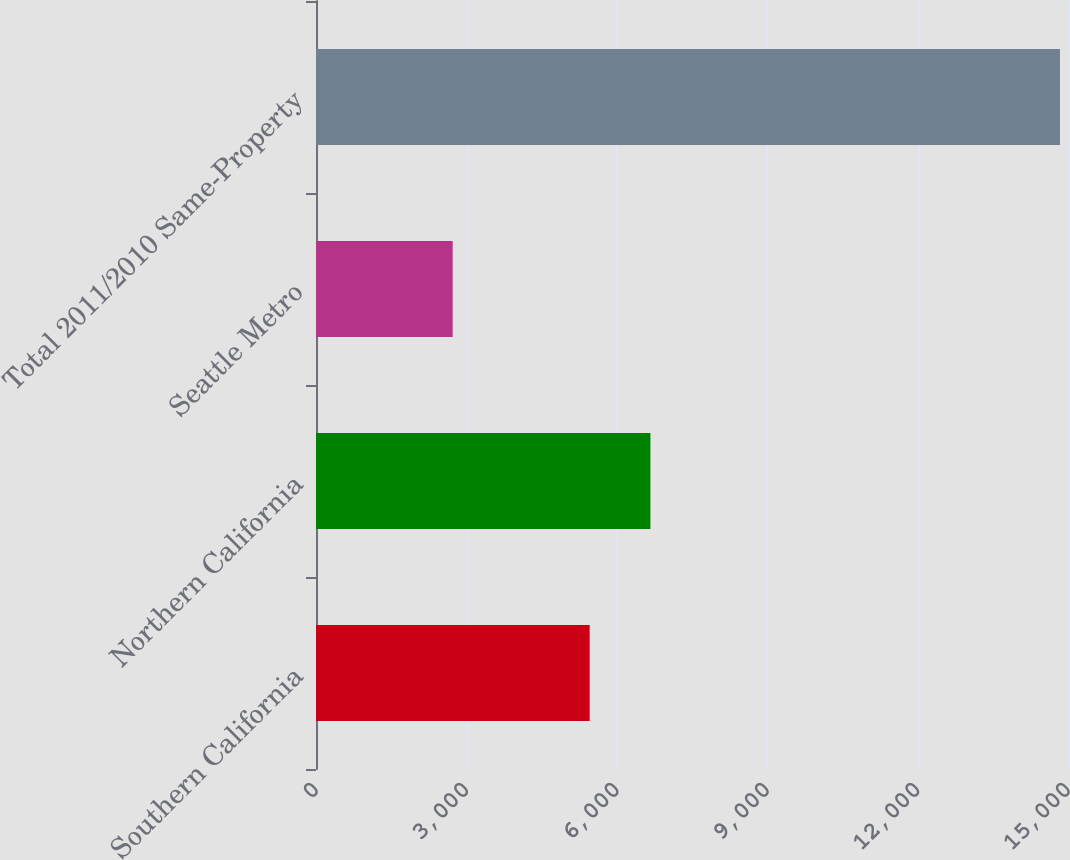Convert chart to OTSL. <chart><loc_0><loc_0><loc_500><loc_500><bar_chart><fcel>Southern California<fcel>Northern California<fcel>Seattle Metro<fcel>Total 2011/2010 Same-Property<nl><fcel>5459<fcel>6670.4<fcel>2726<fcel>14840<nl></chart> 